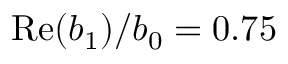Convert formula to latex. <formula><loc_0><loc_0><loc_500><loc_500>R e ( b _ { 1 } ) / b _ { 0 } = 0 . 7 5</formula> 